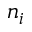Convert formula to latex. <formula><loc_0><loc_0><loc_500><loc_500>n _ { i }</formula> 